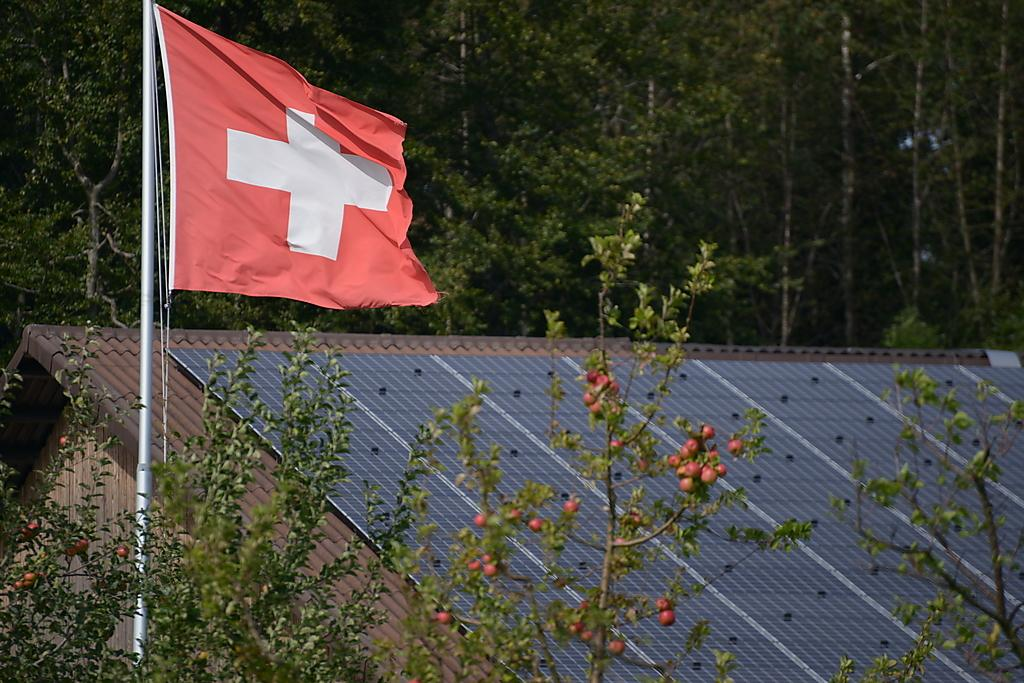What type of structure is visible in the image? There is a house in the image. What other natural elements can be seen in the image? There are trees in the image. What edible items are present in the image? There are fruits in the image. What object is attached to a pole in the image? There is a flag on a pole in the image. What type of transport is visible in the image? There is no transport visible in the image. Where is the key located in the image? There is no key present in the image. 